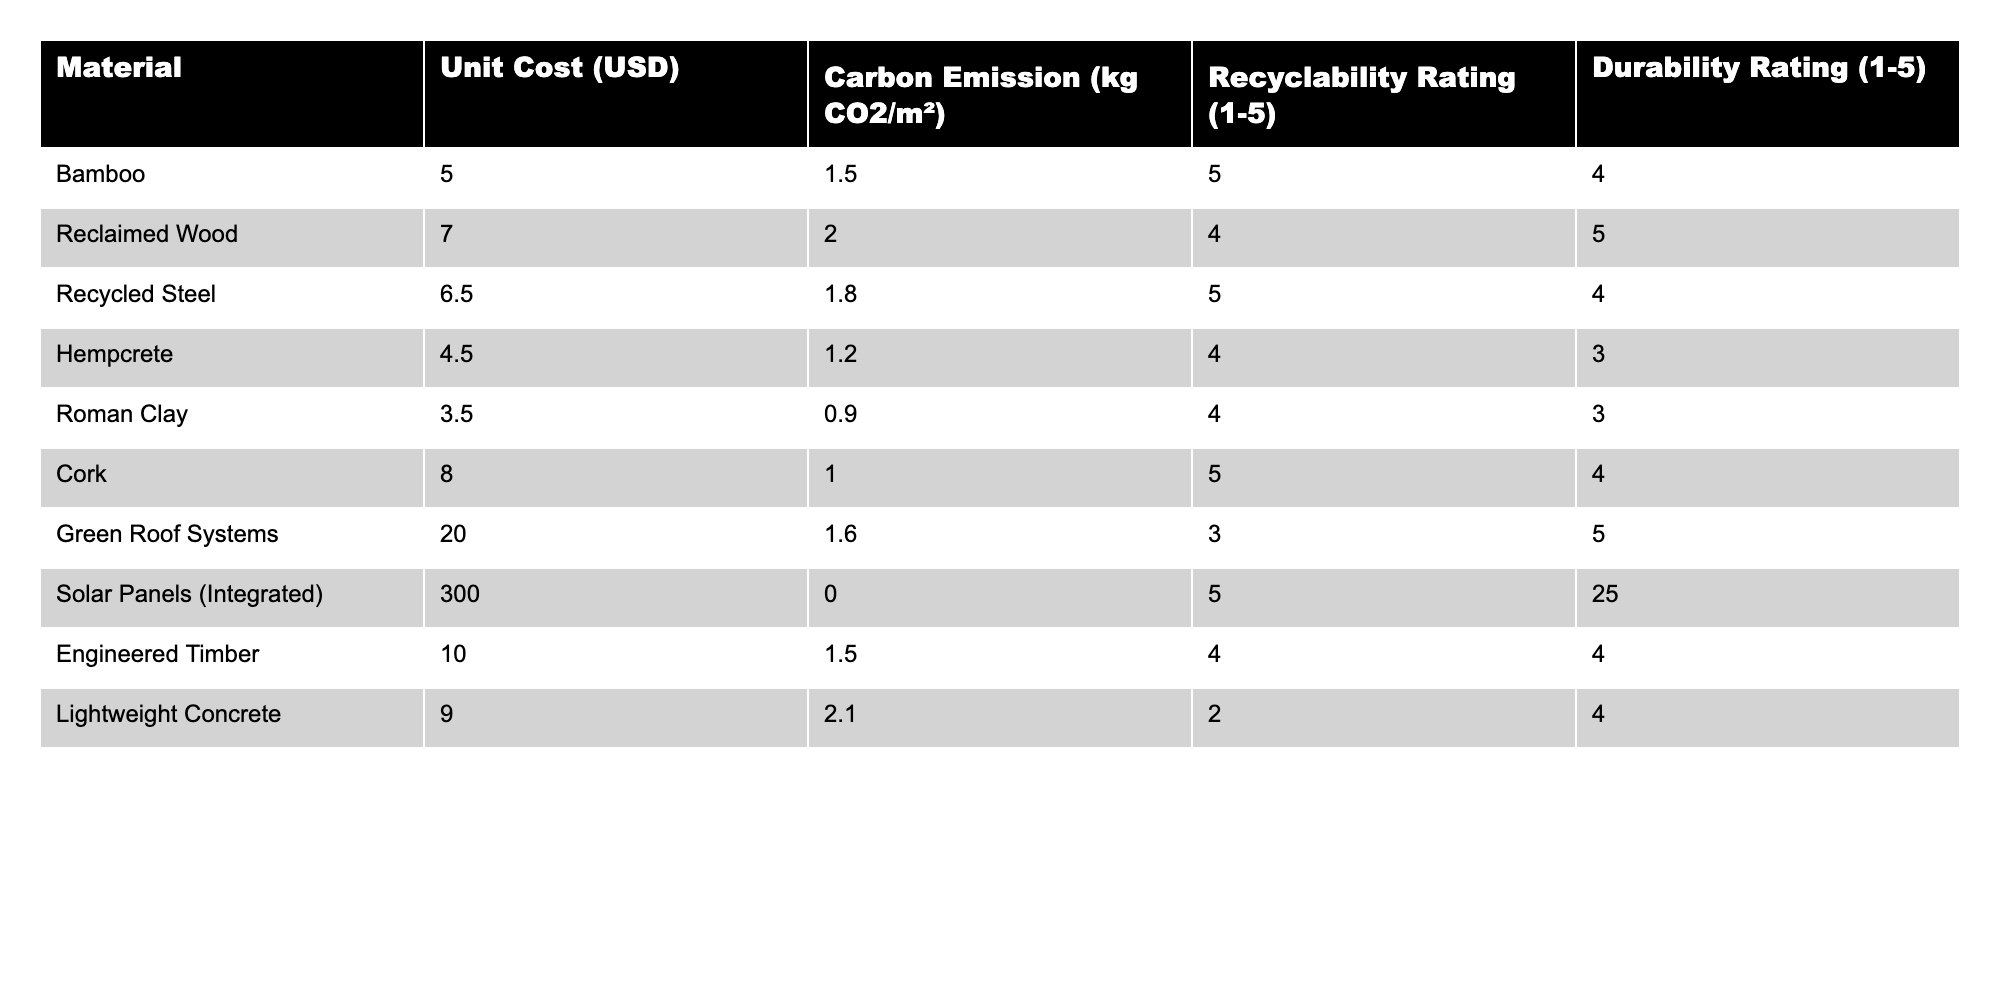What is the unit cost of Roman Clay? Roman Clay is listed in the table, and its corresponding unit cost is presented in the second column. The value for Roman Clay under the Unit Cost (USD) is 3.50.
Answer: 3.50 Which material has the highest recyclability rating? To find the material with the highest recyclability rating, I check the Recyclability Rating column and identify the maximum value, which is 5. The materials that have this rating are Bamboo, Recycled Steel, Cork, and Solar Panels (Integrated).
Answer: Bamboo, Recycled Steel, Cork, Solar Panels (Integrated) What is the average carbon emission for the materials listed? I sum the carbon emissions of all materials (1.50 + 2.00 + 1.80 + 1.20 + 0.90 + 1.00 + 1.60 + 0.00 + 1.50 + 2.10) = 12.60 kg CO2/m². There are 10 materials, so the average is 12.60 / 10 = 1.26 kg CO2/m².
Answer: 1.26 kg CO2/m² Is Cork more expensive than Hempcrete? To answer, I compare the unit costs of both materials. Cork costs 8.00, while Hempcrete costs 4.50. Since 8.00 is greater than 4.50, the statement is true.
Answer: Yes Which material has the lowest durability rating and what is that rating? I examine the Durability Rating column to find the lowest value, which is 3. The materials with this rating are Hempcrete and Roman Clay. Thus, the lowest durability rating is 3, and those materials are indicated.
Answer: Hempcrete and Roman Clay, 3 How much more does Solar Panels (Integrated) cost than the average cost of all other materials? First, I find the total unit cost for all materials except Solar Panels. The sum is (5.00 + 7.00 + 6.50 + 4.50 + 3.50 + 8.00 + 20.00 + 10.00 + 9.00) = 73.50. There are 9 materials, so the average cost is 73.50 / 9 = 8.17. Solar Panels cost 300.00, so the difference is 300.00 - 8.17 = 291.83.
Answer: 291.83 Does the material with the highest durability also have the highest recyclability rating? I look at the material with the highest durability rating, which is Solar Panels (Integrated) with a rating of 5. Its recyclability rating is also 5. So both highest values correspond to the same material.
Answer: Yes How many materials have a unit cost greater than ten dollars? I review the Unit Cost column for values greater than 10. The relevant materials are Green Roof Systems (20.00) and Solar Panels (Integrated) (300.00). There are 2 materials that satisfy this criterion.
Answer: 2 